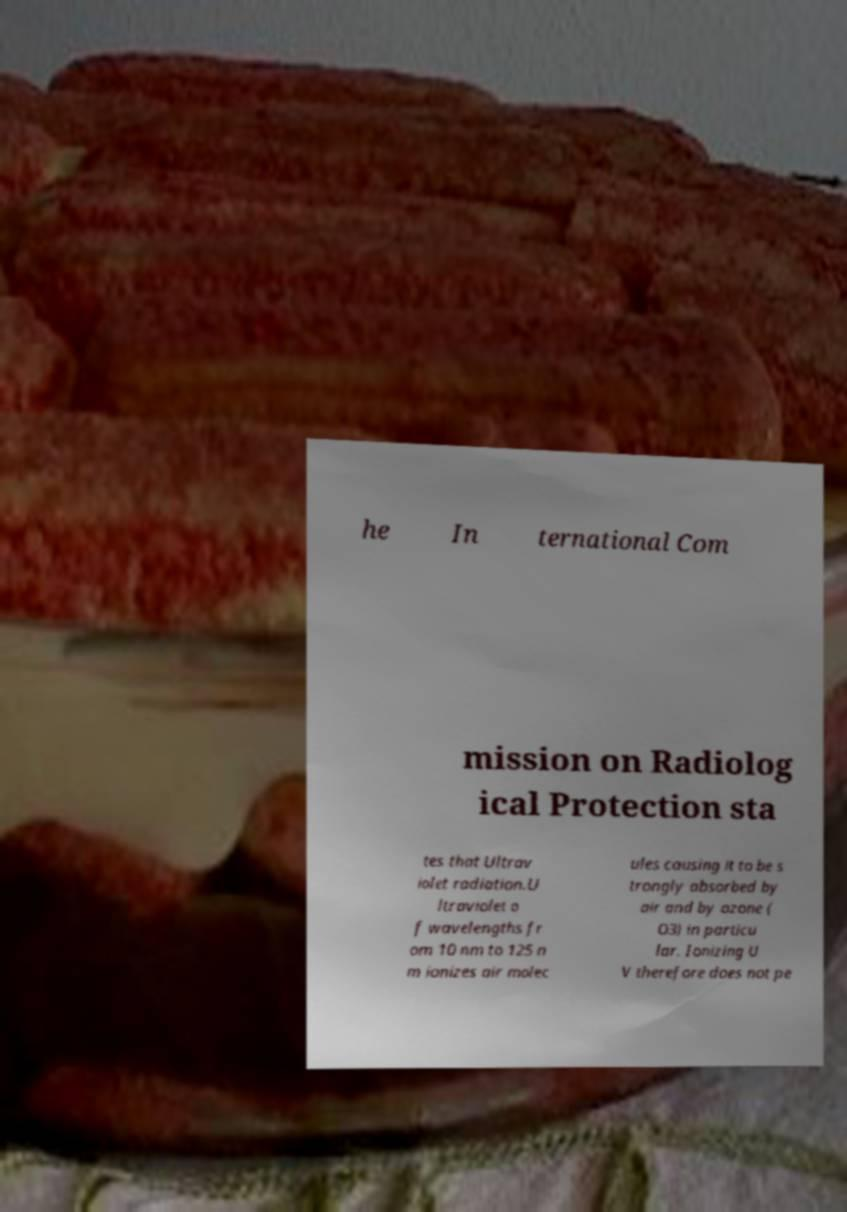For documentation purposes, I need the text within this image transcribed. Could you provide that? he In ternational Com mission on Radiolog ical Protection sta tes that Ultrav iolet radiation.U ltraviolet o f wavelengths fr om 10 nm to 125 n m ionizes air molec ules causing it to be s trongly absorbed by air and by ozone ( O3) in particu lar. Ionizing U V therefore does not pe 